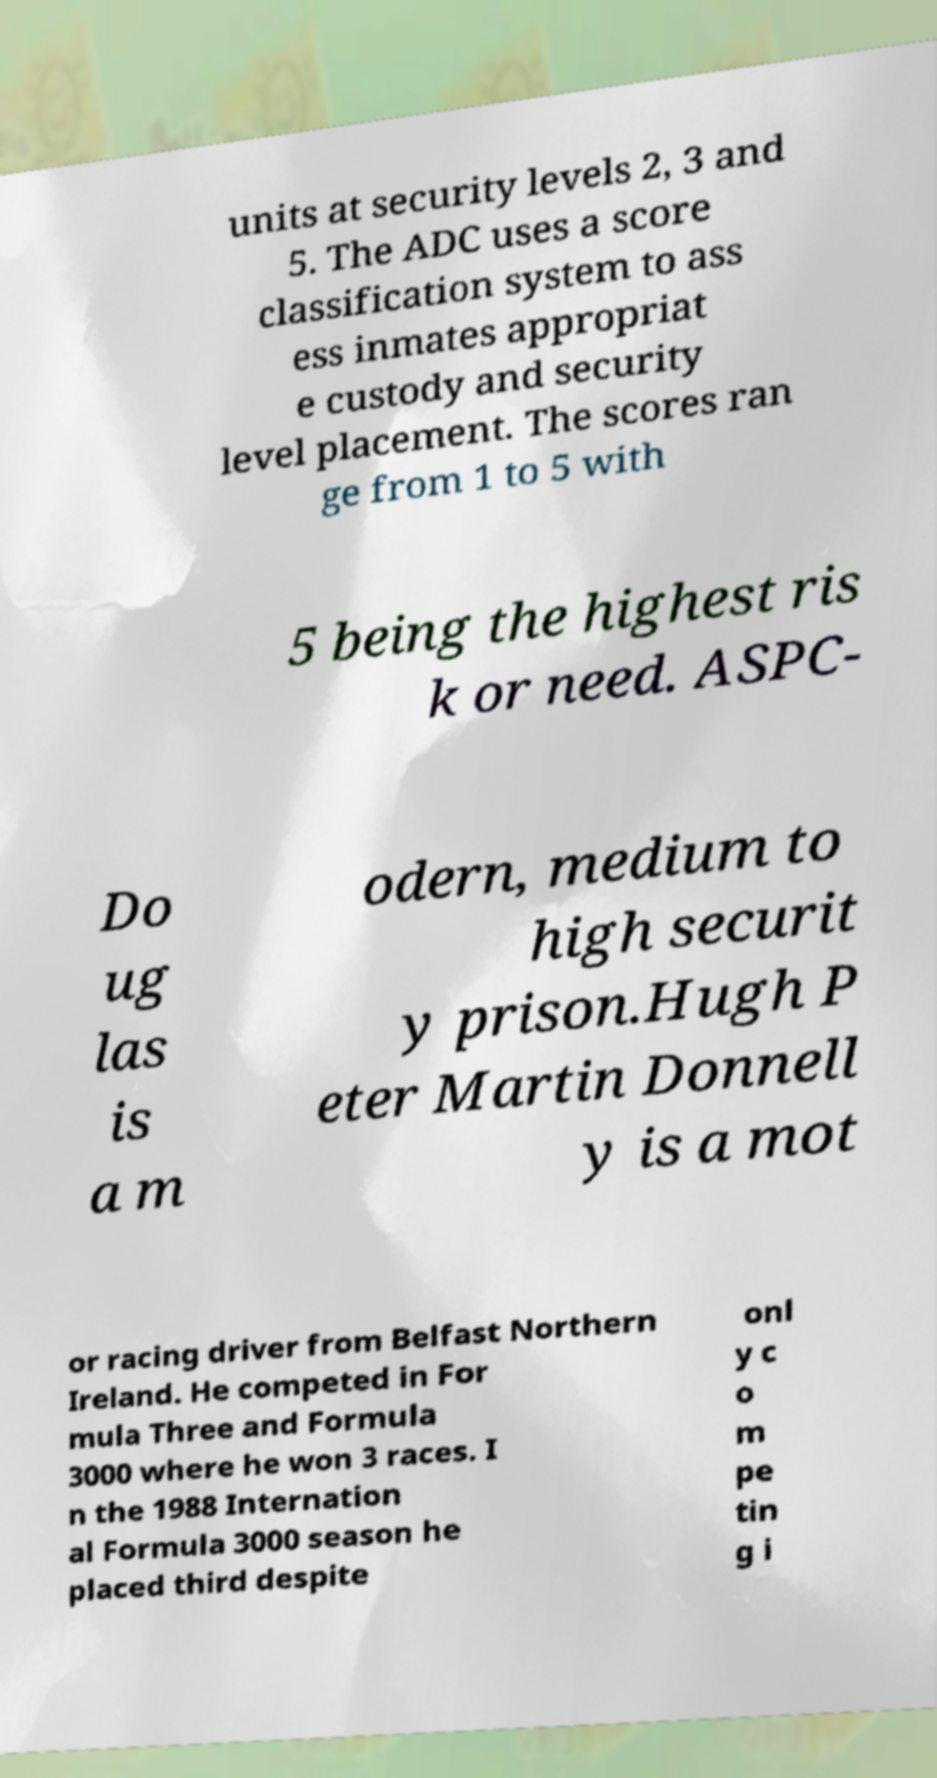Could you assist in decoding the text presented in this image and type it out clearly? units at security levels 2, 3 and 5. The ADC uses a score classification system to ass ess inmates appropriat e custody and security level placement. The scores ran ge from 1 to 5 with 5 being the highest ris k or need. ASPC- Do ug las is a m odern, medium to high securit y prison.Hugh P eter Martin Donnell y is a mot or racing driver from Belfast Northern Ireland. He competed in For mula Three and Formula 3000 where he won 3 races. I n the 1988 Internation al Formula 3000 season he placed third despite onl y c o m pe tin g i 